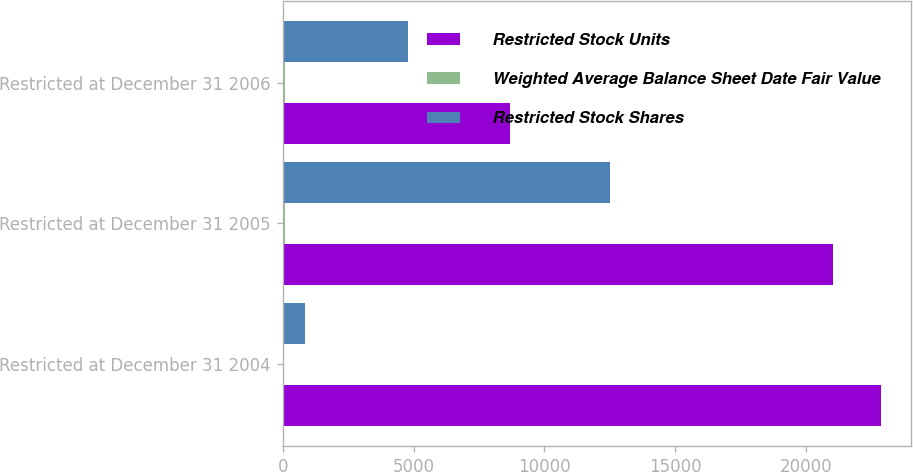Convert chart to OTSL. <chart><loc_0><loc_0><loc_500><loc_500><stacked_bar_chart><ecel><fcel>Restricted at December 31 2004<fcel>Restricted at December 31 2005<fcel>Restricted at December 31 2006<nl><fcel>Restricted Stock Units<fcel>22867<fcel>21019<fcel>8697<nl><fcel>Weighted Average Balance Sheet Date Fair Value<fcel>54.96<fcel>73.19<fcel>85.86<nl><fcel>Restricted Stock Shares<fcel>844<fcel>12504<fcel>4770.5<nl></chart> 